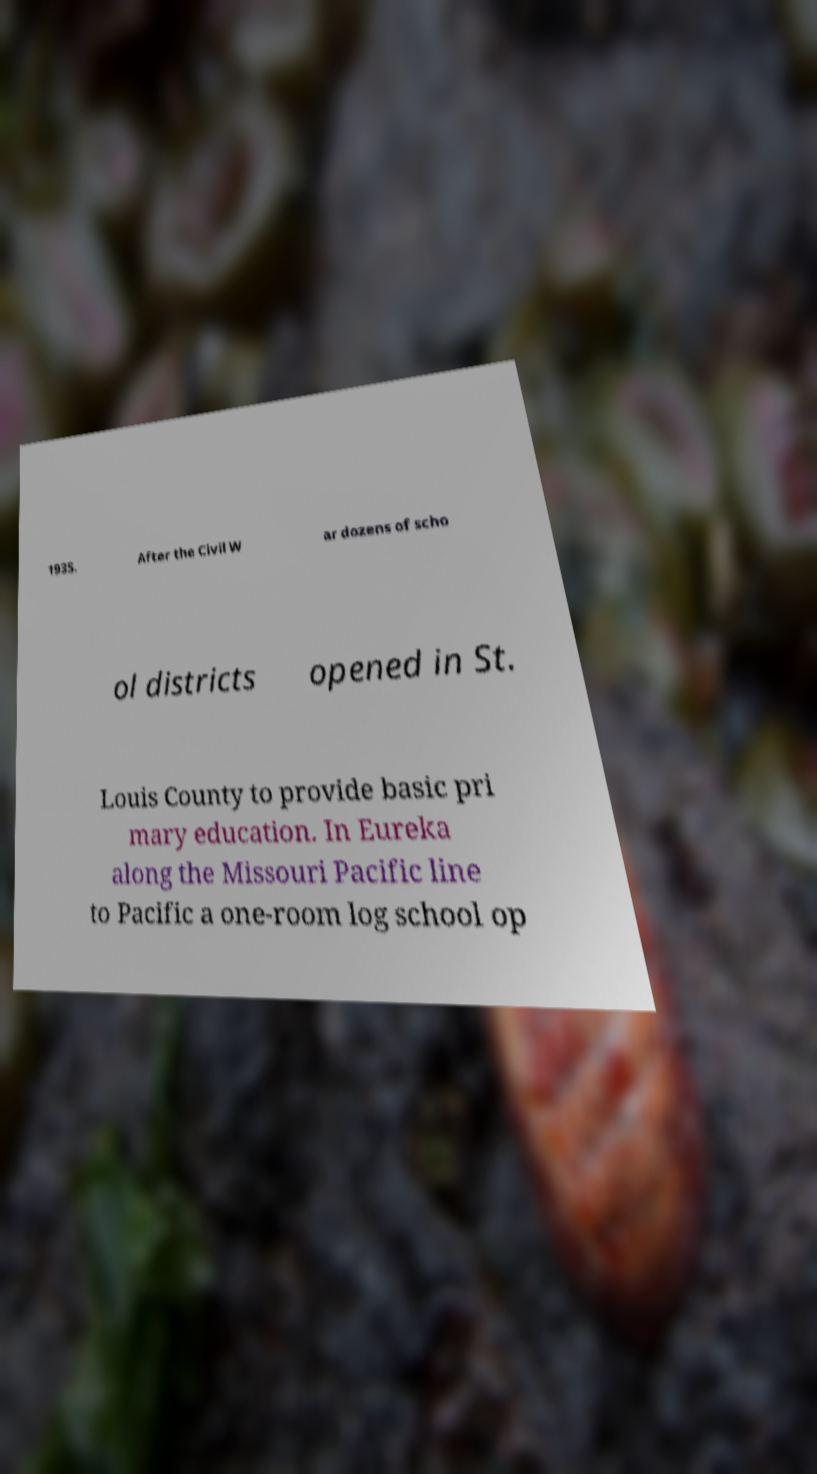For documentation purposes, I need the text within this image transcribed. Could you provide that? 1935. After the Civil W ar dozens of scho ol districts opened in St. Louis County to provide basic pri mary education. In Eureka along the Missouri Pacific line to Pacific a one-room log school op 